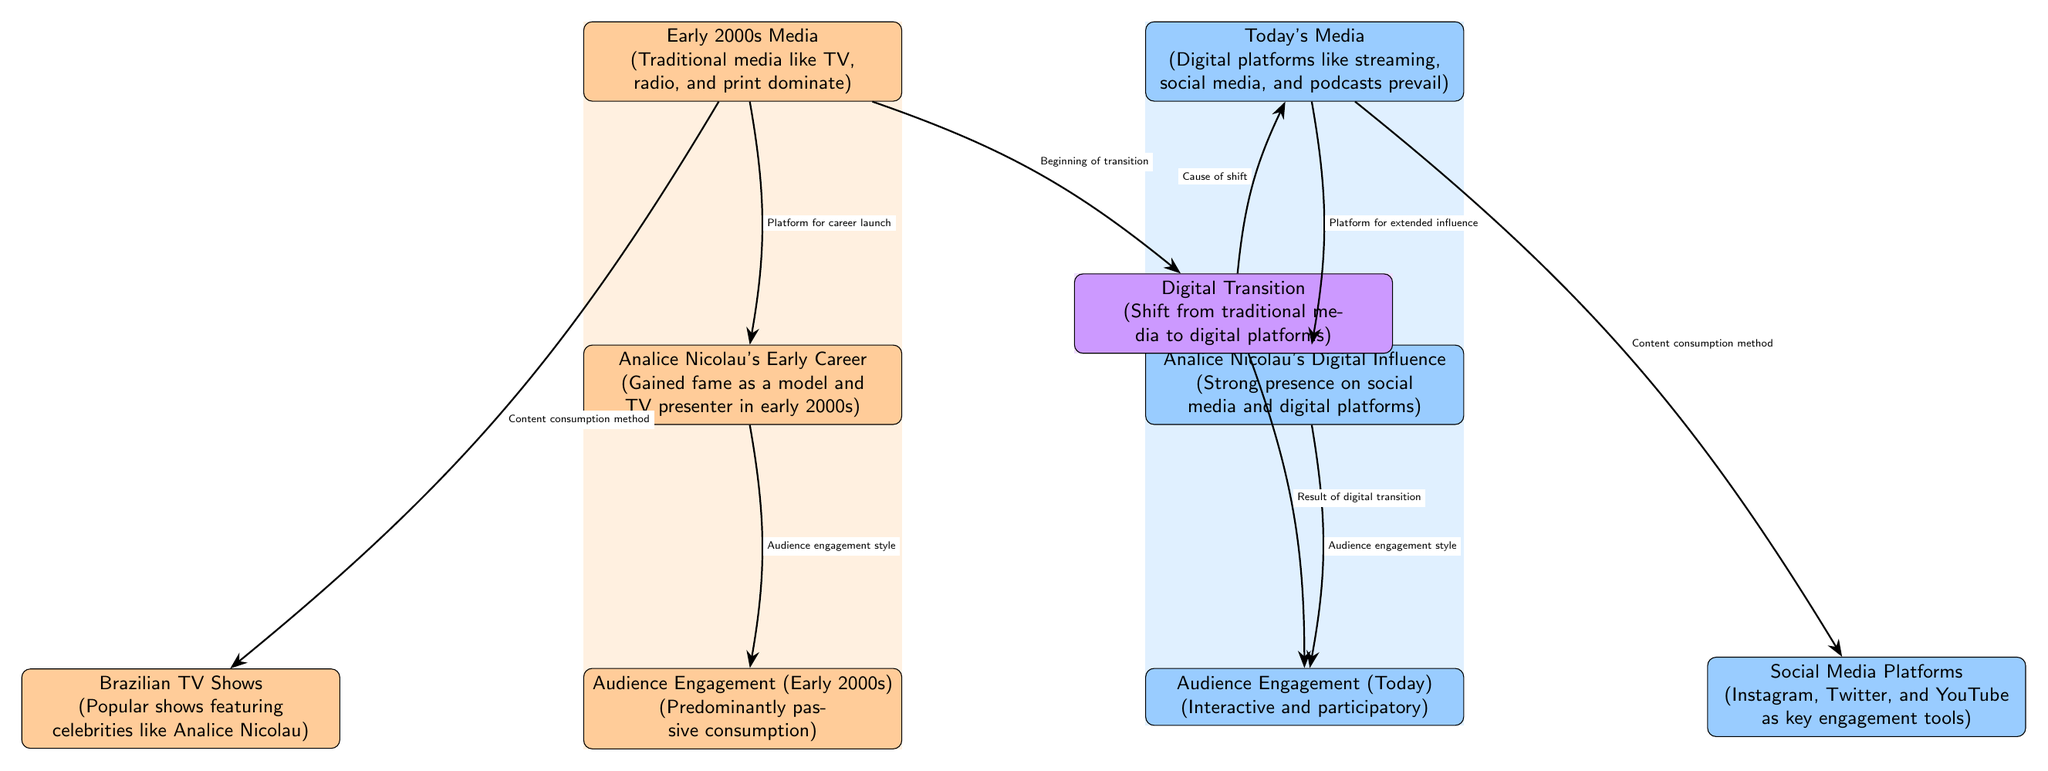What media dominated in the early 2000s? According to the diagram, the early 2000s media was characterized by traditional media such as TV, radio, and print which dominated the landscape.
Answer: Traditional media like TV, radio, and print What is the main audience engagement style in today's media? The diagram indicates that today's media audience engagement is described as interactive and participatory, which highlights a shift from passive consumption in earlier times.
Answer: Interactive and participatory How is Analice Nicolau's early career linked to early 2000s media? The diagram shows that Analice Nicolau's early career gained fame through the early 2000s media, which functioned as a platform for her career launch, thus establishing an important relationship between her influence and the media of that time.
Answer: Platform for career launch What kind of platforms prevail in today's media consumption? According to the diagram, today's media consumption is dominated by digital platforms such as streaming services, social media, and podcasts, which contrast with earlier media forms.
Answer: Digital platforms like streaming, social media, and podcasts What influenced audience engagement transition in the diagram? The transition in audience engagement styles from the early 2000s to today is influenced by the digital transition from traditional media to digital platforms, as evidenced by its positioning in the diagram.
Answer: Digital Transition How many nodes are dedicated to Analice Nicolau's influence in the diagram? The diagram contains two distinct nodes that specifically address Analice Nicolau's influence, one for her early career and another for her current digital influence.
Answer: Two nodes What content consumption method is associated with Brazilian TV shows? The diagram links Brazilian TV shows to content consumption methods characterized by the traditional media landscape of the early 2000s, highlighting their cultural significance during that time.
Answer: Content consumption method What does the transition color in the diagram signify? In the diagram, the transition color signifies the digital transition, indicating a shift from traditional media methods to current digital practices, marking a significant change in the media landscape.
Answer: Shift from traditional media to digital platforms 